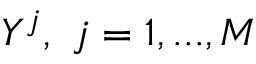<formula> <loc_0><loc_0><loc_500><loc_500>Y ^ { j } , \ j = 1 , \dots , M</formula> 